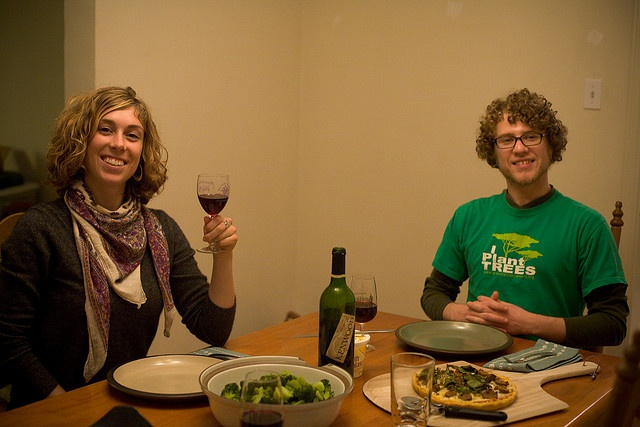Describe the objects in this image and their specific colors. I can see people in black, maroon, and brown tones, dining table in black, brown, olive, and maroon tones, people in black, darkgreen, maroon, and brown tones, bowl in black, olive, tan, and maroon tones, and bottle in black, olive, and maroon tones in this image. 